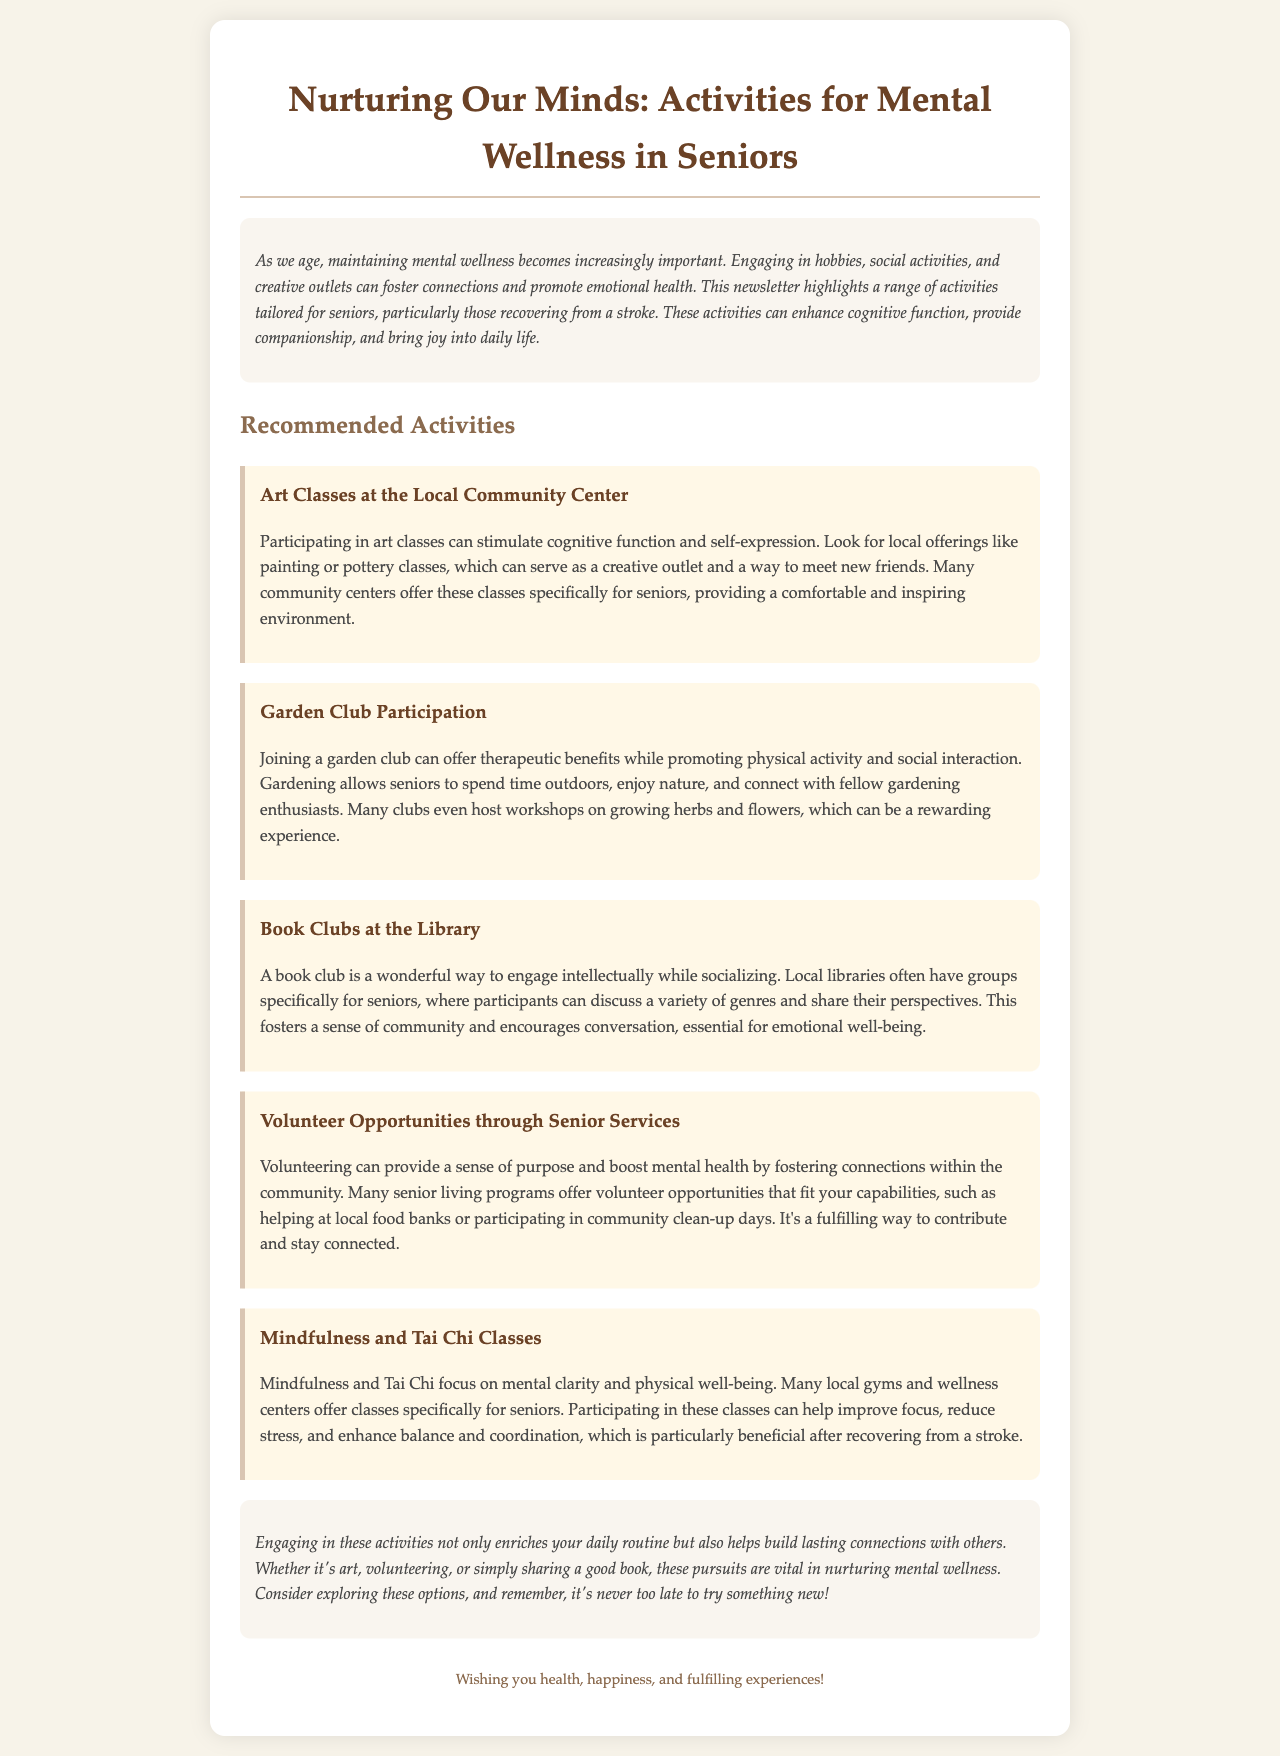What is the title of the newsletter? The title of the newsletter can be found prominently at the top of the document, signaling the topic covered.
Answer: Nurturing Our Minds: Activities for Mental Wellness in Seniors What is one activity recommended for mental wellness? The document lists various activities aimed at promoting mental wellness among seniors, which are detailed in different sections.
Answer: Art Classes at the Local Community Center How many recommended activities are mentioned in the newsletter? By counting the listed activities within the "Recommended Activities" section, we can determine the total number.
Answer: Five Which activity promotes physical activity and social interaction? The newsletter specifies certain activities that not only focus on mental wellness but also encourage physical movement and community engagement.
Answer: Garden Club Participation What type of classes focus on mental clarity and physical well-being? The newsletter mentions specific classes dedicated to enhancing mental and physical health through practice.
Answer: Mindfulness and Tai Chi Classes What is the primary audience for the suggested activities? The newsletter clearly indicates the target audience for the activities outlined within the text.
Answer: Seniors In what type of venue are book clubs offered according to the newsletter? The document specifies locations where some of the recommended activities, including book clubs, take place.
Answer: The Library What is one benefit of volunteering mentioned in the newsletter? The newsletter discusses various positive outcomes of engaging in volunteer work as a recommended activity for seniors.
Answer: Sense of purpose 